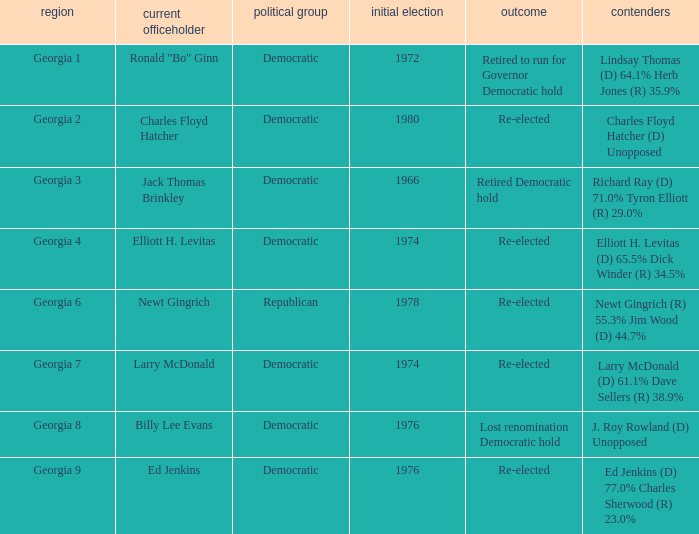I'm looking to parse the entire table for insights. Could you assist me with that? {'header': ['region', 'current officeholder', 'political group', 'initial election', 'outcome', 'contenders'], 'rows': [['Georgia 1', 'Ronald "Bo" Ginn', 'Democratic', '1972', 'Retired to run for Governor Democratic hold', 'Lindsay Thomas (D) 64.1% Herb Jones (R) 35.9%'], ['Georgia 2', 'Charles Floyd Hatcher', 'Democratic', '1980', 'Re-elected', 'Charles Floyd Hatcher (D) Unopposed'], ['Georgia 3', 'Jack Thomas Brinkley', 'Democratic', '1966', 'Retired Democratic hold', 'Richard Ray (D) 71.0% Tyron Elliott (R) 29.0%'], ['Georgia 4', 'Elliott H. Levitas', 'Democratic', '1974', 'Re-elected', 'Elliott H. Levitas (D) 65.5% Dick Winder (R) 34.5%'], ['Georgia 6', 'Newt Gingrich', 'Republican', '1978', 'Re-elected', 'Newt Gingrich (R) 55.3% Jim Wood (D) 44.7%'], ['Georgia 7', 'Larry McDonald', 'Democratic', '1974', 'Re-elected', 'Larry McDonald (D) 61.1% Dave Sellers (R) 38.9%'], ['Georgia 8', 'Billy Lee Evans', 'Democratic', '1976', 'Lost renomination Democratic hold', 'J. Roy Rowland (D) Unopposed'], ['Georgia 9', 'Ed Jenkins', 'Democratic', '1976', 'Re-elected', 'Ed Jenkins (D) 77.0% Charles Sherwood (R) 23.0%']]} Name the party of georgia 4 Democratic. 